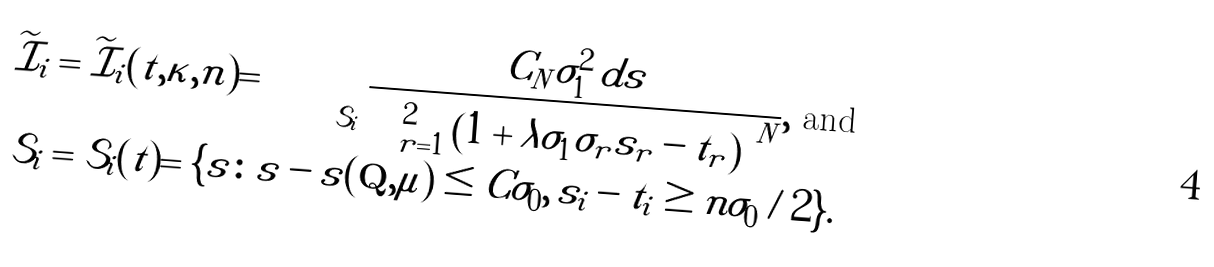<formula> <loc_0><loc_0><loc_500><loc_500>\widetilde { \mathcal { I } } _ { i } & = \widetilde { \mathcal { I } } _ { i } ( t , \kappa , n ) = \iint _ { \mathcal { S } _ { i } } \frac { C _ { N } \sigma _ { 1 } ^ { 2 } \, d s } { \prod _ { r = 1 } ^ { 2 } \left ( 1 + \lambda \sigma _ { 1 } \sigma _ { r } | s _ { r } - t _ { r } | \right ) ^ { N } } , \text { and } \\ \mathcal { S } _ { i } & = \mathcal { S } _ { i } ( t ) = \{ s \colon | s - s ( \mathbf Q , \mu ) | \leq C \sigma _ { 0 } , \, | s _ { i } - t _ { i } | \geq n \sigma _ { 0 } / 2 \} .</formula> 